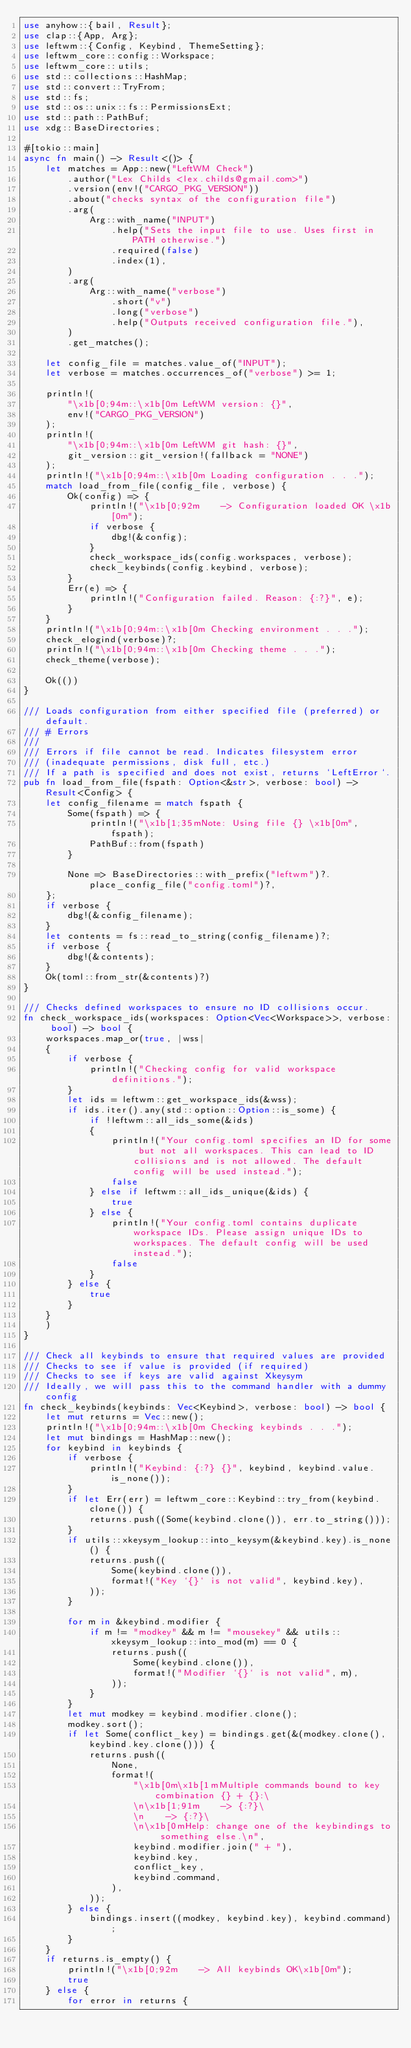<code> <loc_0><loc_0><loc_500><loc_500><_Rust_>use anyhow::{bail, Result};
use clap::{App, Arg};
use leftwm::{Config, Keybind, ThemeSetting};
use leftwm_core::config::Workspace;
use leftwm_core::utils;
use std::collections::HashMap;
use std::convert::TryFrom;
use std::fs;
use std::os::unix::fs::PermissionsExt;
use std::path::PathBuf;
use xdg::BaseDirectories;

#[tokio::main]
async fn main() -> Result<()> {
    let matches = App::new("LeftWM Check")
        .author("Lex Childs <lex.childs@gmail.com>")
        .version(env!("CARGO_PKG_VERSION"))
        .about("checks syntax of the configuration file")
        .arg(
            Arg::with_name("INPUT")
                .help("Sets the input file to use. Uses first in PATH otherwise.")
                .required(false)
                .index(1),
        )
        .arg(
            Arg::with_name("verbose")
                .short("v")
                .long("verbose")
                .help("Outputs received configuration file."),
        )
        .get_matches();

    let config_file = matches.value_of("INPUT");
    let verbose = matches.occurrences_of("verbose") >= 1;

    println!(
        "\x1b[0;94m::\x1b[0m LeftWM version: {}",
        env!("CARGO_PKG_VERSION")
    );
    println!(
        "\x1b[0;94m::\x1b[0m LeftWM git hash: {}",
        git_version::git_version!(fallback = "NONE")
    );
    println!("\x1b[0;94m::\x1b[0m Loading configuration . . .");
    match load_from_file(config_file, verbose) {
        Ok(config) => {
            println!("\x1b[0;92m    -> Configuration loaded OK \x1b[0m");
            if verbose {
                dbg!(&config);
            }
            check_workspace_ids(config.workspaces, verbose);
            check_keybinds(config.keybind, verbose);
        }
        Err(e) => {
            println!("Configuration failed. Reason: {:?}", e);
        }
    }
    println!("\x1b[0;94m::\x1b[0m Checking environment . . .");
    check_elogind(verbose)?;
    println!("\x1b[0;94m::\x1b[0m Checking theme . . .");
    check_theme(verbose);

    Ok(())
}

/// Loads configuration from either specified file (preferred) or default.
/// # Errors
///
/// Errors if file cannot be read. Indicates filesystem error
/// (inadequate permissions, disk full, etc.)
/// If a path is specified and does not exist, returns `LeftError`.
pub fn load_from_file(fspath: Option<&str>, verbose: bool) -> Result<Config> {
    let config_filename = match fspath {
        Some(fspath) => {
            println!("\x1b[1;35mNote: Using file {} \x1b[0m", fspath);
            PathBuf::from(fspath)
        }

        None => BaseDirectories::with_prefix("leftwm")?.place_config_file("config.toml")?,
    };
    if verbose {
        dbg!(&config_filename);
    }
    let contents = fs::read_to_string(config_filename)?;
    if verbose {
        dbg!(&contents);
    }
    Ok(toml::from_str(&contents)?)
}

/// Checks defined workspaces to ensure no ID collisions occur.
fn check_workspace_ids(workspaces: Option<Vec<Workspace>>, verbose: bool) -> bool {
    workspaces.map_or(true, |wss|
    {
        if verbose {
            println!("Checking config for valid workspace definitions.");
        }
        let ids = leftwm::get_workspace_ids(&wss);
        if ids.iter().any(std::option::Option::is_some) {
            if !leftwm::all_ids_some(&ids)
            {
                println!("Your config.toml specifies an ID for some but not all workspaces. This can lead to ID collisions and is not allowed. The default config will be used instead.");
                false
            } else if leftwm::all_ids_unique(&ids) {
                true
            } else {
                println!("Your config.toml contains duplicate workspace IDs. Please assign unique IDs to workspaces. The default config will be used instead.");
                false
            }
        } else {
            true
        }
    }
    )
}

/// Check all keybinds to ensure that required values are provided
/// Checks to see if value is provided (if required)
/// Checks to see if keys are valid against Xkeysym
/// Ideally, we will pass this to the command handler with a dummy config
fn check_keybinds(keybinds: Vec<Keybind>, verbose: bool) -> bool {
    let mut returns = Vec::new();
    println!("\x1b[0;94m::\x1b[0m Checking keybinds . . .");
    let mut bindings = HashMap::new();
    for keybind in keybinds {
        if verbose {
            println!("Keybind: {:?} {}", keybind, keybind.value.is_none());
        }
        if let Err(err) = leftwm_core::Keybind::try_from(keybind.clone()) {
            returns.push((Some(keybind.clone()), err.to_string()));
        }
        if utils::xkeysym_lookup::into_keysym(&keybind.key).is_none() {
            returns.push((
                Some(keybind.clone()),
                format!("Key `{}` is not valid", keybind.key),
            ));
        }

        for m in &keybind.modifier {
            if m != "modkey" && m != "mousekey" && utils::xkeysym_lookup::into_mod(m) == 0 {
                returns.push((
                    Some(keybind.clone()),
                    format!("Modifier `{}` is not valid", m),
                ));
            }
        }
        let mut modkey = keybind.modifier.clone();
        modkey.sort();
        if let Some(conflict_key) = bindings.get(&(modkey.clone(), keybind.key.clone())) {
            returns.push((
                None,
                format!(
                    "\x1b[0m\x1b[1mMultiple commands bound to key combination {} + {}:\
                    \n\x1b[1;91m    -> {:?}\
                    \n    -> {:?}\
                    \n\x1b[0mHelp: change one of the keybindings to something else.\n",
                    keybind.modifier.join(" + "),
                    keybind.key,
                    conflict_key,
                    keybind.command,
                ),
            ));
        } else {
            bindings.insert((modkey, keybind.key), keybind.command);
        }
    }
    if returns.is_empty() {
        println!("\x1b[0;92m    -> All keybinds OK\x1b[0m");
        true
    } else {
        for error in returns {</code> 